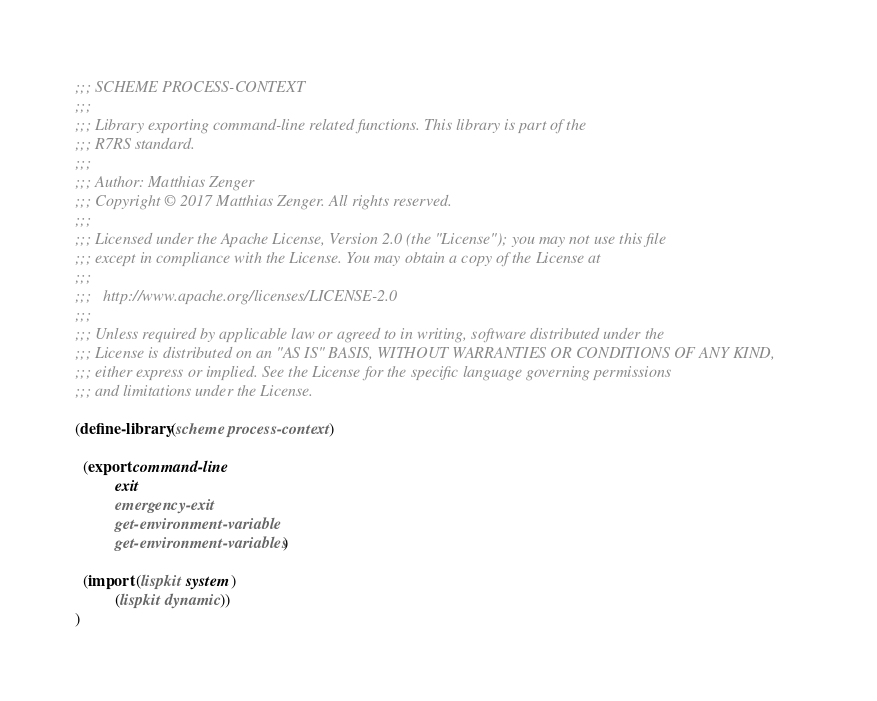<code> <loc_0><loc_0><loc_500><loc_500><_Scheme_>;;; SCHEME PROCESS-CONTEXT
;;;
;;; Library exporting command-line related functions. This library is part of the
;;; R7RS standard.
;;;
;;; Author: Matthias Zenger
;;; Copyright © 2017 Matthias Zenger. All rights reserved.
;;;
;;; Licensed under the Apache License, Version 2.0 (the "License"); you may not use this file
;;; except in compliance with the License. You may obtain a copy of the License at
;;;
;;;   http://www.apache.org/licenses/LICENSE-2.0
;;;
;;; Unless required by applicable law or agreed to in writing, software distributed under the
;;; License is distributed on an "AS IS" BASIS, WITHOUT WARRANTIES OR CONDITIONS OF ANY KIND,
;;; either express or implied. See the License for the specific language governing permissions
;;; and limitations under the License.

(define-library (scheme process-context)

  (export command-line
          exit
          emergency-exit
          get-environment-variable
          get-environment-variables)

  (import (lispkit system)
          (lispkit dynamic))
)
</code> 